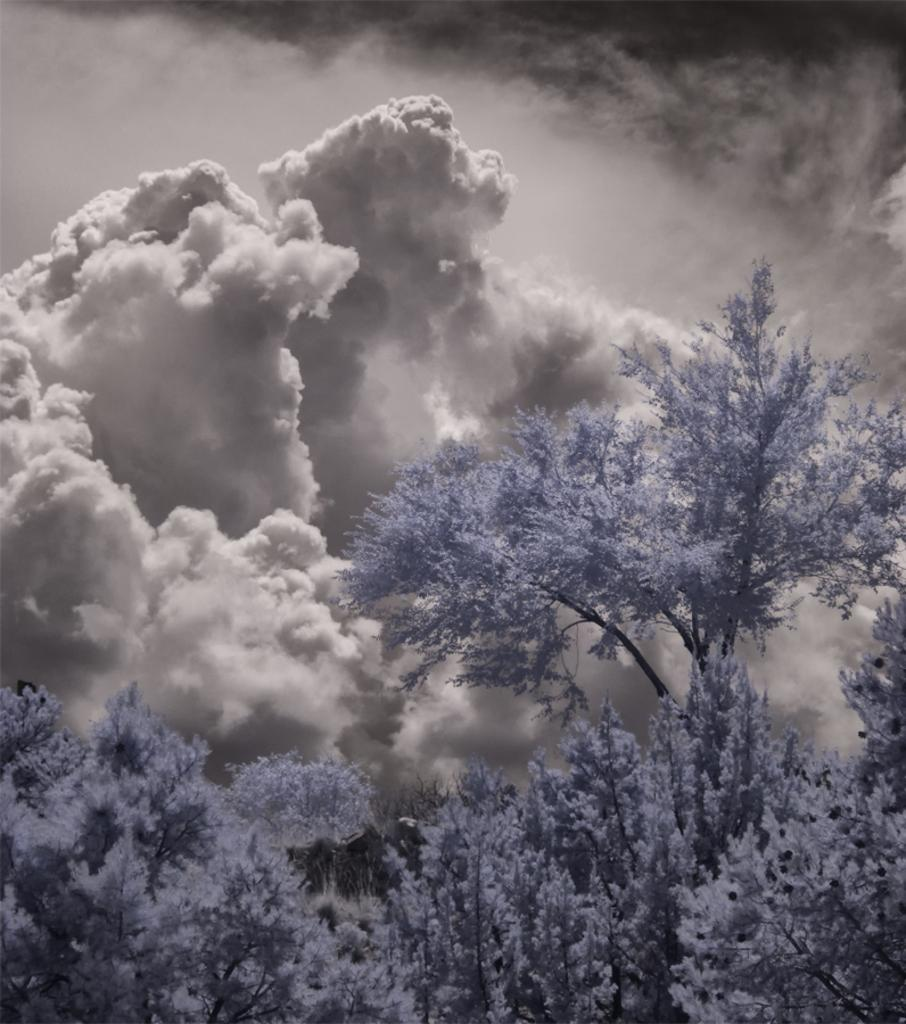What type of vegetation can be seen in the image? There are trees in the image. What is the condition of the sky in the image? The sky is cloudy in the image. What type of distribution system is present in the image? There is no distribution system mentioned or visible in the image. Can you identify any jewels in the image? There are no jewels present in the image; it features trees and a cloudy sky. 